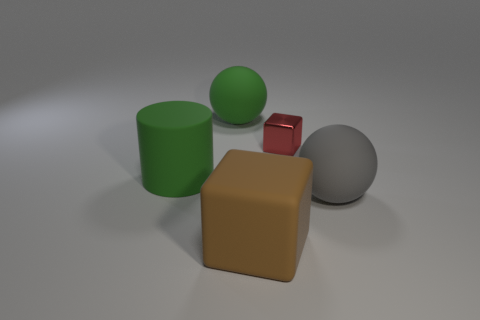The big thing that is both to the right of the green rubber ball and on the left side of the gray rubber object has what shape?
Your response must be concise. Cube. How many objects are either matte spheres that are on the right side of the big brown matte thing or gray matte balls to the right of the rubber cylinder?
Ensure brevity in your answer.  1. Is the number of big green things in front of the green rubber sphere the same as the number of big brown blocks to the left of the red metal object?
Give a very brief answer. Yes. What shape is the large green matte object in front of the big green rubber object behind the red object?
Give a very brief answer. Cylinder. Is there another object of the same shape as the large brown thing?
Offer a very short reply. Yes. What number of big blue rubber objects are there?
Provide a succinct answer. 0. Are the cube that is right of the large brown object and the big block made of the same material?
Ensure brevity in your answer.  No. Is there a purple matte ball that has the same size as the cylinder?
Your answer should be very brief. No. Does the red metallic thing have the same shape as the big green object behind the small red shiny thing?
Your response must be concise. No. There is a matte object that is left of the matte thing that is behind the green cylinder; are there any big blocks left of it?
Your answer should be very brief. No. 